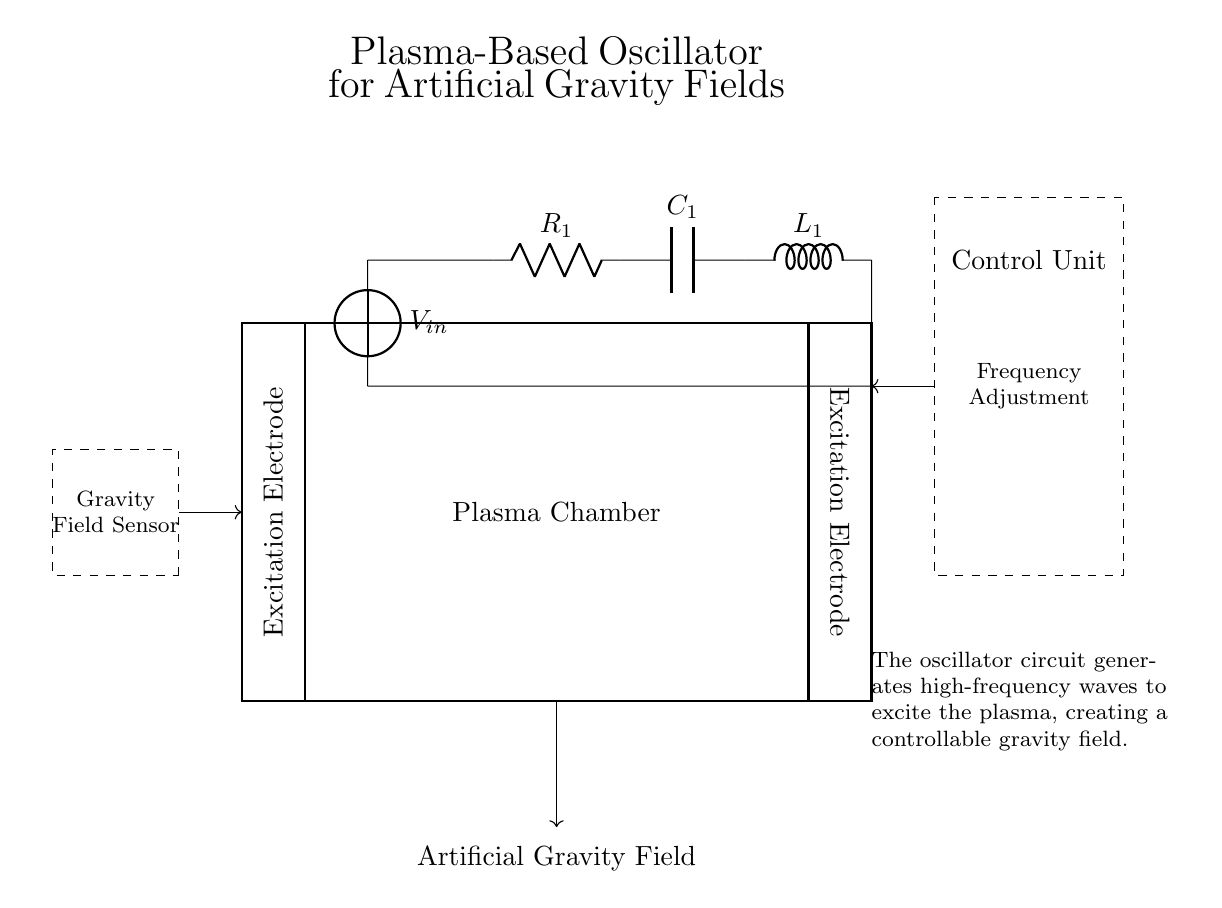What is the input voltage for this oscillator circuit? The input voltage is labeled as V in the circuit diagram, which is the source voltage supplying the circuit.
Answer: V in What are the components present in the oscillator circuit? The components listed include a resistor (R1), a capacitor (C1), and an inductor (L1). These are typical components found in an oscillator circuit responsible for generating oscillations.
Answer: R1, C1, L1 What does the oscillator control unit do? The control unit allows adjustments to the frequency of the oscillator, indicated by the arrow labeled "Frequency Adjustment" in the circuit.
Answer: Frequency Adjustment How are the excitation electrodes oriented in relation to the plasma chamber? The excitation electrodes are drawn vertically and connect at the top and bottom of the plasma chamber, showing their role in exciting the plasma.
Answer: Vertically How does this oscillator generate an artificial gravity field? The oscillator generates high-frequency waves through its circuit, which excite the plasma in the chamber. This excitation creates a controllable gravity field, as indicated by the explanatory notes.
Answer: Exciting plasma What is the purpose of the gravity field sensor in this circuit? The gravity field sensor measures the output of the generated gravity field and provides feedback to the control unit, allowing for adjustments as necessary.
Answer: Feedback for adjustments What is the overall function of the plasma chamber in this oscillator? The plasma chamber serves to contain the plasma that is excited by the oscillator, and it is where the transformation of waves into an artificial gravity field occurs.
Answer: Contain excited plasma 